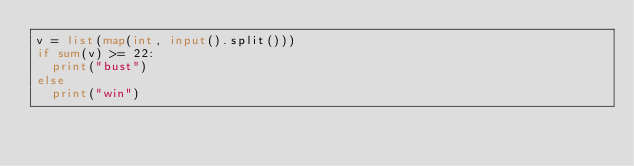Convert code to text. <code><loc_0><loc_0><loc_500><loc_500><_Python_>v = list(map(int, input().split()))
if sum(v) >= 22:
  print("bust")
else
  print("win")</code> 